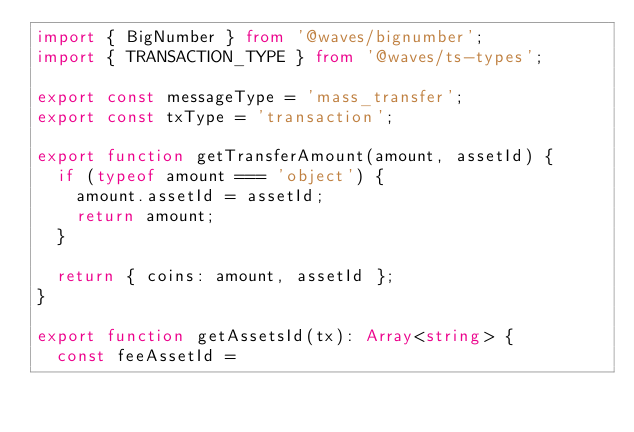<code> <loc_0><loc_0><loc_500><loc_500><_TypeScript_>import { BigNumber } from '@waves/bignumber';
import { TRANSACTION_TYPE } from '@waves/ts-types';

export const messageType = 'mass_transfer';
export const txType = 'transaction';

export function getTransferAmount(amount, assetId) {
  if (typeof amount === 'object') {
    amount.assetId = assetId;
    return amount;
  }

  return { coins: amount, assetId };
}

export function getAssetsId(tx): Array<string> {
  const feeAssetId =</code> 